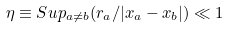<formula> <loc_0><loc_0><loc_500><loc_500>\eta \equiv S u p _ { a \neq b } ( r _ { a } / | x _ { a } - x _ { b } | ) \ll 1</formula> 